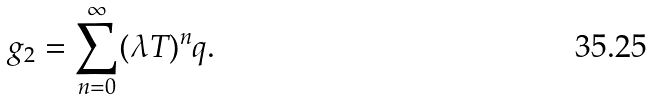<formula> <loc_0><loc_0><loc_500><loc_500>g _ { 2 } = \sum _ { n = 0 } ^ { \infty } ( \lambda T ) ^ { n } q .</formula> 